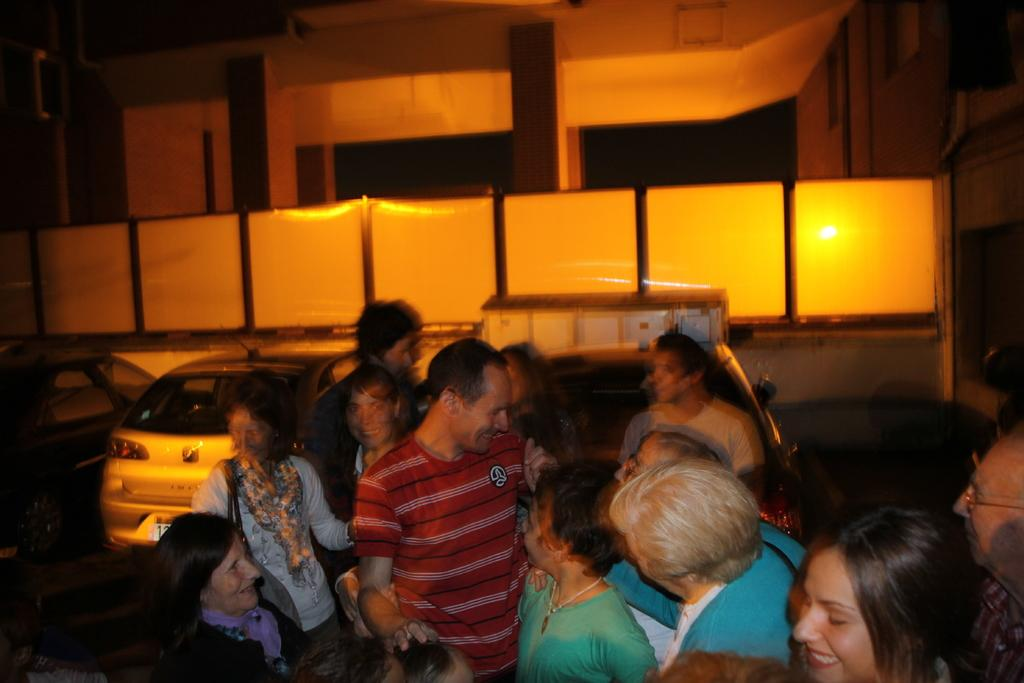What can be seen at the bottom of the image? There are people standing at the bottom of the image. What is located on the left side of the image? There is a car on the left side of the image. What is visible in the background of the image? There is a building and a fence in the background of the image. Where is the kettle located in the image? There is no kettle present in the image. What type of kitten can be seen playing with the pump in the image? There is no kitten or pump present in the image. 